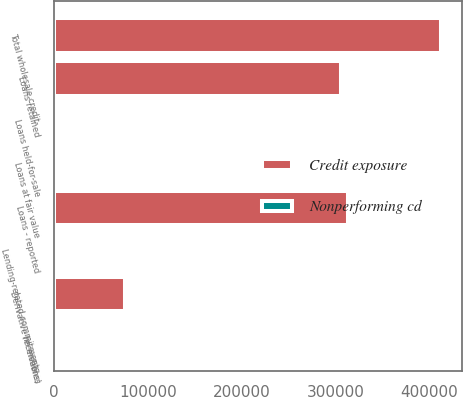<chart> <loc_0><loc_0><loc_500><loc_500><stacked_bar_chart><ecel><fcel>(in millions)<fcel>Loans retained<fcel>Loans held-for-sale<fcel>Loans at fair value<fcel>Loans - reported<fcel>Derivative receivables<fcel>Total wholesale credit-<fcel>Lending-related commitments<nl><fcel>Credit exposure<fcel>2012<fcel>306222<fcel>4406<fcel>2555<fcel>313183<fcel>74983<fcel>411814<fcel>2012<nl><fcel>Nonperforming cd<fcel>2012<fcel>1434<fcel>18<fcel>93<fcel>1545<fcel>239<fcel>1784<fcel>355<nl></chart> 